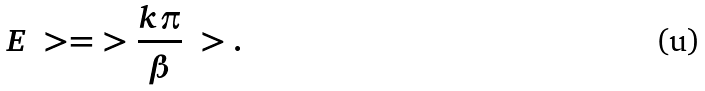<formula> <loc_0><loc_0><loc_500><loc_500>E \ > = \ > \frac { k \pi } { \beta } \ > .</formula> 